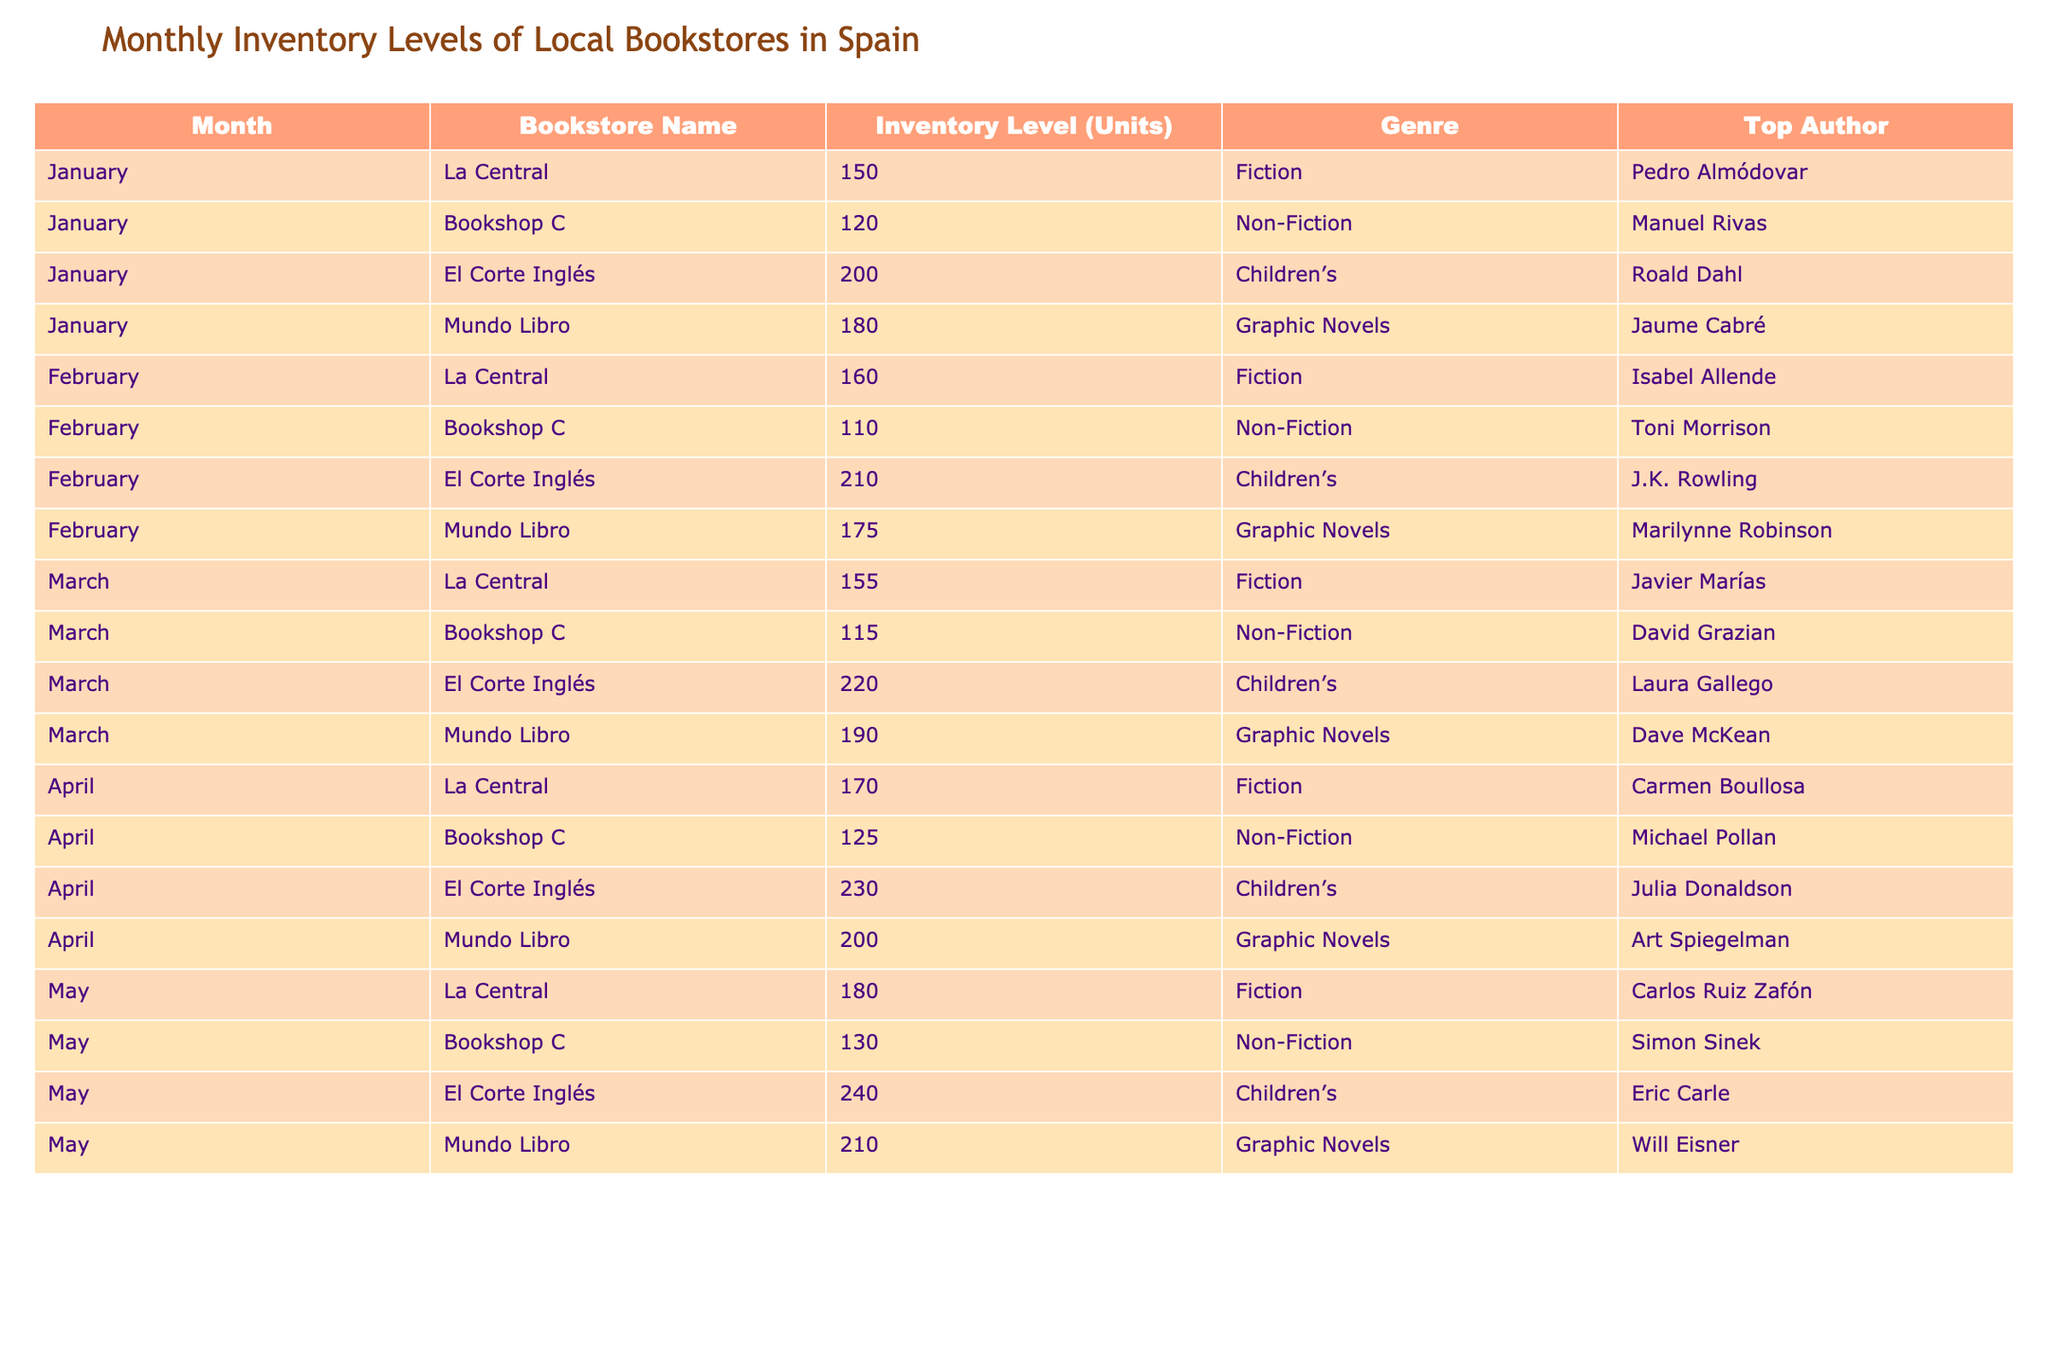What is the inventory level of El Corte Inglés in February? According to the table, the inventory level of El Corte Inglés in February is listed as 210 units.
Answer: 210 Which bookstore had the highest inventory level in April? By reviewing the table, we see that El Corte Inglés had an inventory level of 230 units in April, which is the highest among all bookstores for that month.
Answer: El Corte Inglés What is the average inventory level across all bookstores in March? To find the average for March, we sum the inventory levels: (155 + 115 + 220 + 190) = 680 units. There are 4 bookstores, so we divide 680 by 4, resulting in an average inventory level of 170 units.
Answer: 170 Is the top author for Mundo Libro in May the same as in January? Looking at the table, in January the top author for Mundo Libro is Jaume Cabré and in May it is Will Eisner, which are different authors. Thus, the statement is false.
Answer: No What is the total inventory level of La Central from January to May? By adding the inventory levels for La Central across those months: (150 + 160 + 155 + 170 + 180) = 815 units total.
Answer: 815 How many units of Graphic Novels did Mundo Libro have in total over the five months? Examining the table, the inventory levels for Mundo Libro in Graphic Novels are: 180 (January) + 175 (February) + 190 (March) + 200 (April) + 210 (May), which sums to 1035 units.
Answer: 1035 In which month did Bookshop C have the lowest inventory level? By checking the inventory levels for Bookshop C, they are: 120 (January), 110 (February), 115 (March), 125 (April), and 130 (May). February shows the lowest number at 110 units.
Answer: February Which genre had the highest inventory level at El Corte Inglés in May? In May, El Corte Inglés had an inventory level of 240 units in the Children’s genre. To find the highest genre for El Corte Inglés, we compare it to other months; in May, Children’s is the only genre listed. Hence, it is the highest for that month.
Answer: Children’s 